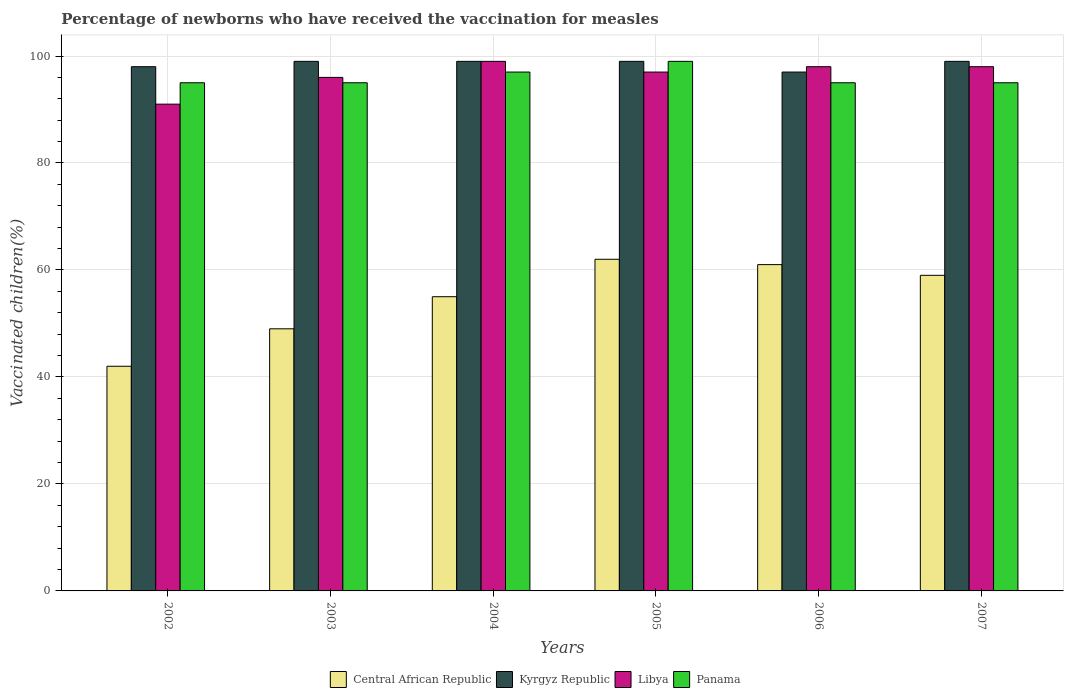How many different coloured bars are there?
Your response must be concise. 4. How many bars are there on the 6th tick from the left?
Your answer should be very brief. 4. How many bars are there on the 2nd tick from the right?
Keep it short and to the point. 4. In how many cases, is the number of bars for a given year not equal to the number of legend labels?
Offer a terse response. 0. What is the percentage of vaccinated children in Kyrgyz Republic in 2006?
Your answer should be very brief. 97. Across all years, what is the maximum percentage of vaccinated children in Kyrgyz Republic?
Provide a succinct answer. 99. Across all years, what is the minimum percentage of vaccinated children in Libya?
Offer a very short reply. 91. In which year was the percentage of vaccinated children in Panama maximum?
Give a very brief answer. 2005. What is the total percentage of vaccinated children in Kyrgyz Republic in the graph?
Your response must be concise. 591. What is the difference between the percentage of vaccinated children in Panama in 2003 and that in 2007?
Offer a terse response. 0. What is the difference between the percentage of vaccinated children in Central African Republic in 2007 and the percentage of vaccinated children in Libya in 2002?
Your answer should be compact. -32. What is the average percentage of vaccinated children in Libya per year?
Provide a short and direct response. 96.5. In the year 2004, what is the difference between the percentage of vaccinated children in Panama and percentage of vaccinated children in Kyrgyz Republic?
Keep it short and to the point. -2. In how many years, is the percentage of vaccinated children in Panama greater than 44 %?
Your answer should be very brief. 6. What is the ratio of the percentage of vaccinated children in Panama in 2004 to that in 2005?
Your response must be concise. 0.98. Is the difference between the percentage of vaccinated children in Panama in 2002 and 2004 greater than the difference between the percentage of vaccinated children in Kyrgyz Republic in 2002 and 2004?
Offer a terse response. No. What is the difference between the highest and the second highest percentage of vaccinated children in Libya?
Make the answer very short. 1. In how many years, is the percentage of vaccinated children in Central African Republic greater than the average percentage of vaccinated children in Central African Republic taken over all years?
Offer a very short reply. 4. What does the 2nd bar from the left in 2002 represents?
Make the answer very short. Kyrgyz Republic. What does the 1st bar from the right in 2002 represents?
Provide a succinct answer. Panama. Is it the case that in every year, the sum of the percentage of vaccinated children in Kyrgyz Republic and percentage of vaccinated children in Panama is greater than the percentage of vaccinated children in Libya?
Offer a very short reply. Yes. How many years are there in the graph?
Your answer should be compact. 6. Does the graph contain any zero values?
Your answer should be very brief. No. Does the graph contain grids?
Your answer should be very brief. Yes. Where does the legend appear in the graph?
Give a very brief answer. Bottom center. How are the legend labels stacked?
Provide a succinct answer. Horizontal. What is the title of the graph?
Give a very brief answer. Percentage of newborns who have received the vaccination for measles. Does "Yemen, Rep." appear as one of the legend labels in the graph?
Your response must be concise. No. What is the label or title of the Y-axis?
Offer a terse response. Vaccinated children(%). What is the Vaccinated children(%) in Libya in 2002?
Provide a short and direct response. 91. What is the Vaccinated children(%) in Panama in 2002?
Offer a very short reply. 95. What is the Vaccinated children(%) in Central African Republic in 2003?
Provide a succinct answer. 49. What is the Vaccinated children(%) of Libya in 2003?
Your response must be concise. 96. What is the Vaccinated children(%) of Panama in 2003?
Offer a terse response. 95. What is the Vaccinated children(%) of Central African Republic in 2004?
Provide a short and direct response. 55. What is the Vaccinated children(%) in Panama in 2004?
Give a very brief answer. 97. What is the Vaccinated children(%) of Central African Republic in 2005?
Your response must be concise. 62. What is the Vaccinated children(%) of Kyrgyz Republic in 2005?
Offer a terse response. 99. What is the Vaccinated children(%) of Libya in 2005?
Make the answer very short. 97. What is the Vaccinated children(%) in Panama in 2005?
Your response must be concise. 99. What is the Vaccinated children(%) in Kyrgyz Republic in 2006?
Provide a succinct answer. 97. What is the Vaccinated children(%) in Libya in 2006?
Keep it short and to the point. 98. What is the Vaccinated children(%) of Panama in 2006?
Offer a very short reply. 95. What is the Vaccinated children(%) of Kyrgyz Republic in 2007?
Keep it short and to the point. 99. What is the Vaccinated children(%) of Libya in 2007?
Your answer should be compact. 98. Across all years, what is the maximum Vaccinated children(%) of Central African Republic?
Make the answer very short. 62. Across all years, what is the maximum Vaccinated children(%) of Kyrgyz Republic?
Give a very brief answer. 99. Across all years, what is the maximum Vaccinated children(%) in Libya?
Provide a succinct answer. 99. Across all years, what is the minimum Vaccinated children(%) in Central African Republic?
Ensure brevity in your answer.  42. Across all years, what is the minimum Vaccinated children(%) in Kyrgyz Republic?
Make the answer very short. 97. Across all years, what is the minimum Vaccinated children(%) of Libya?
Offer a very short reply. 91. Across all years, what is the minimum Vaccinated children(%) of Panama?
Your answer should be compact. 95. What is the total Vaccinated children(%) in Central African Republic in the graph?
Provide a succinct answer. 328. What is the total Vaccinated children(%) in Kyrgyz Republic in the graph?
Offer a very short reply. 591. What is the total Vaccinated children(%) in Libya in the graph?
Your response must be concise. 579. What is the total Vaccinated children(%) in Panama in the graph?
Offer a terse response. 576. What is the difference between the Vaccinated children(%) in Central African Republic in 2002 and that in 2003?
Provide a succinct answer. -7. What is the difference between the Vaccinated children(%) of Panama in 2002 and that in 2004?
Give a very brief answer. -2. What is the difference between the Vaccinated children(%) of Panama in 2002 and that in 2005?
Provide a short and direct response. -4. What is the difference between the Vaccinated children(%) in Kyrgyz Republic in 2002 and that in 2006?
Your answer should be very brief. 1. What is the difference between the Vaccinated children(%) of Panama in 2002 and that in 2006?
Your response must be concise. 0. What is the difference between the Vaccinated children(%) in Kyrgyz Republic in 2002 and that in 2007?
Offer a very short reply. -1. What is the difference between the Vaccinated children(%) in Libya in 2002 and that in 2007?
Your answer should be very brief. -7. What is the difference between the Vaccinated children(%) in Kyrgyz Republic in 2003 and that in 2004?
Give a very brief answer. 0. What is the difference between the Vaccinated children(%) of Central African Republic in 2003 and that in 2005?
Keep it short and to the point. -13. What is the difference between the Vaccinated children(%) in Libya in 2003 and that in 2005?
Provide a succinct answer. -1. What is the difference between the Vaccinated children(%) in Panama in 2003 and that in 2005?
Keep it short and to the point. -4. What is the difference between the Vaccinated children(%) in Panama in 2003 and that in 2006?
Your answer should be very brief. 0. What is the difference between the Vaccinated children(%) in Central African Republic in 2003 and that in 2007?
Offer a very short reply. -10. What is the difference between the Vaccinated children(%) in Kyrgyz Republic in 2004 and that in 2005?
Keep it short and to the point. 0. What is the difference between the Vaccinated children(%) in Libya in 2004 and that in 2005?
Offer a terse response. 2. What is the difference between the Vaccinated children(%) of Panama in 2004 and that in 2005?
Offer a very short reply. -2. What is the difference between the Vaccinated children(%) in Kyrgyz Republic in 2004 and that in 2006?
Keep it short and to the point. 2. What is the difference between the Vaccinated children(%) in Libya in 2004 and that in 2006?
Your answer should be compact. 1. What is the difference between the Vaccinated children(%) in Panama in 2004 and that in 2007?
Provide a succinct answer. 2. What is the difference between the Vaccinated children(%) in Panama in 2005 and that in 2006?
Keep it short and to the point. 4. What is the difference between the Vaccinated children(%) of Central African Republic in 2005 and that in 2007?
Offer a very short reply. 3. What is the difference between the Vaccinated children(%) of Panama in 2005 and that in 2007?
Ensure brevity in your answer.  4. What is the difference between the Vaccinated children(%) of Central African Republic in 2006 and that in 2007?
Your answer should be compact. 2. What is the difference between the Vaccinated children(%) of Kyrgyz Republic in 2006 and that in 2007?
Your response must be concise. -2. What is the difference between the Vaccinated children(%) in Panama in 2006 and that in 2007?
Offer a terse response. 0. What is the difference between the Vaccinated children(%) in Central African Republic in 2002 and the Vaccinated children(%) in Kyrgyz Republic in 2003?
Your answer should be compact. -57. What is the difference between the Vaccinated children(%) of Central African Republic in 2002 and the Vaccinated children(%) of Libya in 2003?
Your answer should be very brief. -54. What is the difference between the Vaccinated children(%) of Central African Republic in 2002 and the Vaccinated children(%) of Panama in 2003?
Offer a terse response. -53. What is the difference between the Vaccinated children(%) in Kyrgyz Republic in 2002 and the Vaccinated children(%) in Libya in 2003?
Your response must be concise. 2. What is the difference between the Vaccinated children(%) in Libya in 2002 and the Vaccinated children(%) in Panama in 2003?
Provide a succinct answer. -4. What is the difference between the Vaccinated children(%) of Central African Republic in 2002 and the Vaccinated children(%) of Kyrgyz Republic in 2004?
Your answer should be very brief. -57. What is the difference between the Vaccinated children(%) in Central African Republic in 2002 and the Vaccinated children(%) in Libya in 2004?
Keep it short and to the point. -57. What is the difference between the Vaccinated children(%) in Central African Republic in 2002 and the Vaccinated children(%) in Panama in 2004?
Offer a very short reply. -55. What is the difference between the Vaccinated children(%) in Kyrgyz Republic in 2002 and the Vaccinated children(%) in Libya in 2004?
Give a very brief answer. -1. What is the difference between the Vaccinated children(%) of Central African Republic in 2002 and the Vaccinated children(%) of Kyrgyz Republic in 2005?
Your answer should be compact. -57. What is the difference between the Vaccinated children(%) of Central African Republic in 2002 and the Vaccinated children(%) of Libya in 2005?
Your answer should be very brief. -55. What is the difference between the Vaccinated children(%) of Central African Republic in 2002 and the Vaccinated children(%) of Panama in 2005?
Give a very brief answer. -57. What is the difference between the Vaccinated children(%) of Kyrgyz Republic in 2002 and the Vaccinated children(%) of Libya in 2005?
Provide a succinct answer. 1. What is the difference between the Vaccinated children(%) of Kyrgyz Republic in 2002 and the Vaccinated children(%) of Panama in 2005?
Your answer should be compact. -1. What is the difference between the Vaccinated children(%) in Libya in 2002 and the Vaccinated children(%) in Panama in 2005?
Make the answer very short. -8. What is the difference between the Vaccinated children(%) in Central African Republic in 2002 and the Vaccinated children(%) in Kyrgyz Republic in 2006?
Ensure brevity in your answer.  -55. What is the difference between the Vaccinated children(%) of Central African Republic in 2002 and the Vaccinated children(%) of Libya in 2006?
Make the answer very short. -56. What is the difference between the Vaccinated children(%) in Central African Republic in 2002 and the Vaccinated children(%) in Panama in 2006?
Provide a short and direct response. -53. What is the difference between the Vaccinated children(%) in Libya in 2002 and the Vaccinated children(%) in Panama in 2006?
Give a very brief answer. -4. What is the difference between the Vaccinated children(%) of Central African Republic in 2002 and the Vaccinated children(%) of Kyrgyz Republic in 2007?
Ensure brevity in your answer.  -57. What is the difference between the Vaccinated children(%) in Central African Republic in 2002 and the Vaccinated children(%) in Libya in 2007?
Your answer should be compact. -56. What is the difference between the Vaccinated children(%) in Central African Republic in 2002 and the Vaccinated children(%) in Panama in 2007?
Ensure brevity in your answer.  -53. What is the difference between the Vaccinated children(%) in Kyrgyz Republic in 2002 and the Vaccinated children(%) in Libya in 2007?
Provide a succinct answer. 0. What is the difference between the Vaccinated children(%) in Kyrgyz Republic in 2002 and the Vaccinated children(%) in Panama in 2007?
Your answer should be compact. 3. What is the difference between the Vaccinated children(%) in Libya in 2002 and the Vaccinated children(%) in Panama in 2007?
Your answer should be compact. -4. What is the difference between the Vaccinated children(%) of Central African Republic in 2003 and the Vaccinated children(%) of Kyrgyz Republic in 2004?
Offer a terse response. -50. What is the difference between the Vaccinated children(%) in Central African Republic in 2003 and the Vaccinated children(%) in Libya in 2004?
Offer a terse response. -50. What is the difference between the Vaccinated children(%) of Central African Republic in 2003 and the Vaccinated children(%) of Panama in 2004?
Your answer should be compact. -48. What is the difference between the Vaccinated children(%) in Kyrgyz Republic in 2003 and the Vaccinated children(%) in Panama in 2004?
Ensure brevity in your answer.  2. What is the difference between the Vaccinated children(%) in Central African Republic in 2003 and the Vaccinated children(%) in Kyrgyz Republic in 2005?
Offer a terse response. -50. What is the difference between the Vaccinated children(%) in Central African Republic in 2003 and the Vaccinated children(%) in Libya in 2005?
Offer a terse response. -48. What is the difference between the Vaccinated children(%) in Libya in 2003 and the Vaccinated children(%) in Panama in 2005?
Offer a terse response. -3. What is the difference between the Vaccinated children(%) in Central African Republic in 2003 and the Vaccinated children(%) in Kyrgyz Republic in 2006?
Provide a succinct answer. -48. What is the difference between the Vaccinated children(%) in Central African Republic in 2003 and the Vaccinated children(%) in Libya in 2006?
Give a very brief answer. -49. What is the difference between the Vaccinated children(%) of Central African Republic in 2003 and the Vaccinated children(%) of Panama in 2006?
Offer a terse response. -46. What is the difference between the Vaccinated children(%) of Kyrgyz Republic in 2003 and the Vaccinated children(%) of Panama in 2006?
Offer a very short reply. 4. What is the difference between the Vaccinated children(%) in Central African Republic in 2003 and the Vaccinated children(%) in Kyrgyz Republic in 2007?
Your answer should be compact. -50. What is the difference between the Vaccinated children(%) of Central African Republic in 2003 and the Vaccinated children(%) of Libya in 2007?
Offer a terse response. -49. What is the difference between the Vaccinated children(%) of Central African Republic in 2003 and the Vaccinated children(%) of Panama in 2007?
Provide a succinct answer. -46. What is the difference between the Vaccinated children(%) of Kyrgyz Republic in 2003 and the Vaccinated children(%) of Libya in 2007?
Offer a terse response. 1. What is the difference between the Vaccinated children(%) of Kyrgyz Republic in 2003 and the Vaccinated children(%) of Panama in 2007?
Offer a very short reply. 4. What is the difference between the Vaccinated children(%) in Central African Republic in 2004 and the Vaccinated children(%) in Kyrgyz Republic in 2005?
Give a very brief answer. -44. What is the difference between the Vaccinated children(%) in Central African Republic in 2004 and the Vaccinated children(%) in Libya in 2005?
Offer a very short reply. -42. What is the difference between the Vaccinated children(%) in Central African Republic in 2004 and the Vaccinated children(%) in Panama in 2005?
Provide a short and direct response. -44. What is the difference between the Vaccinated children(%) of Central African Republic in 2004 and the Vaccinated children(%) of Kyrgyz Republic in 2006?
Make the answer very short. -42. What is the difference between the Vaccinated children(%) of Central African Republic in 2004 and the Vaccinated children(%) of Libya in 2006?
Give a very brief answer. -43. What is the difference between the Vaccinated children(%) in Kyrgyz Republic in 2004 and the Vaccinated children(%) in Libya in 2006?
Offer a terse response. 1. What is the difference between the Vaccinated children(%) of Kyrgyz Republic in 2004 and the Vaccinated children(%) of Panama in 2006?
Offer a terse response. 4. What is the difference between the Vaccinated children(%) in Central African Republic in 2004 and the Vaccinated children(%) in Kyrgyz Republic in 2007?
Give a very brief answer. -44. What is the difference between the Vaccinated children(%) of Central African Republic in 2004 and the Vaccinated children(%) of Libya in 2007?
Your response must be concise. -43. What is the difference between the Vaccinated children(%) in Kyrgyz Republic in 2004 and the Vaccinated children(%) in Libya in 2007?
Give a very brief answer. 1. What is the difference between the Vaccinated children(%) of Libya in 2004 and the Vaccinated children(%) of Panama in 2007?
Your response must be concise. 4. What is the difference between the Vaccinated children(%) in Central African Republic in 2005 and the Vaccinated children(%) in Kyrgyz Republic in 2006?
Make the answer very short. -35. What is the difference between the Vaccinated children(%) of Central African Republic in 2005 and the Vaccinated children(%) of Libya in 2006?
Make the answer very short. -36. What is the difference between the Vaccinated children(%) in Central African Republic in 2005 and the Vaccinated children(%) in Panama in 2006?
Your answer should be compact. -33. What is the difference between the Vaccinated children(%) in Kyrgyz Republic in 2005 and the Vaccinated children(%) in Libya in 2006?
Keep it short and to the point. 1. What is the difference between the Vaccinated children(%) of Libya in 2005 and the Vaccinated children(%) of Panama in 2006?
Provide a short and direct response. 2. What is the difference between the Vaccinated children(%) in Central African Republic in 2005 and the Vaccinated children(%) in Kyrgyz Republic in 2007?
Your response must be concise. -37. What is the difference between the Vaccinated children(%) of Central African Republic in 2005 and the Vaccinated children(%) of Libya in 2007?
Ensure brevity in your answer.  -36. What is the difference between the Vaccinated children(%) of Central African Republic in 2005 and the Vaccinated children(%) of Panama in 2007?
Ensure brevity in your answer.  -33. What is the difference between the Vaccinated children(%) of Kyrgyz Republic in 2005 and the Vaccinated children(%) of Libya in 2007?
Your response must be concise. 1. What is the difference between the Vaccinated children(%) in Central African Republic in 2006 and the Vaccinated children(%) in Kyrgyz Republic in 2007?
Keep it short and to the point. -38. What is the difference between the Vaccinated children(%) in Central African Republic in 2006 and the Vaccinated children(%) in Libya in 2007?
Give a very brief answer. -37. What is the difference between the Vaccinated children(%) in Central African Republic in 2006 and the Vaccinated children(%) in Panama in 2007?
Provide a short and direct response. -34. What is the difference between the Vaccinated children(%) in Kyrgyz Republic in 2006 and the Vaccinated children(%) in Libya in 2007?
Keep it short and to the point. -1. What is the difference between the Vaccinated children(%) in Libya in 2006 and the Vaccinated children(%) in Panama in 2007?
Your answer should be compact. 3. What is the average Vaccinated children(%) of Central African Republic per year?
Make the answer very short. 54.67. What is the average Vaccinated children(%) in Kyrgyz Republic per year?
Give a very brief answer. 98.5. What is the average Vaccinated children(%) of Libya per year?
Ensure brevity in your answer.  96.5. What is the average Vaccinated children(%) in Panama per year?
Provide a short and direct response. 96. In the year 2002, what is the difference between the Vaccinated children(%) of Central African Republic and Vaccinated children(%) of Kyrgyz Republic?
Ensure brevity in your answer.  -56. In the year 2002, what is the difference between the Vaccinated children(%) of Central African Republic and Vaccinated children(%) of Libya?
Offer a terse response. -49. In the year 2002, what is the difference between the Vaccinated children(%) in Central African Republic and Vaccinated children(%) in Panama?
Provide a short and direct response. -53. In the year 2002, what is the difference between the Vaccinated children(%) of Kyrgyz Republic and Vaccinated children(%) of Libya?
Your response must be concise. 7. In the year 2002, what is the difference between the Vaccinated children(%) in Kyrgyz Republic and Vaccinated children(%) in Panama?
Make the answer very short. 3. In the year 2003, what is the difference between the Vaccinated children(%) of Central African Republic and Vaccinated children(%) of Kyrgyz Republic?
Your response must be concise. -50. In the year 2003, what is the difference between the Vaccinated children(%) in Central African Republic and Vaccinated children(%) in Libya?
Provide a succinct answer. -47. In the year 2003, what is the difference between the Vaccinated children(%) in Central African Republic and Vaccinated children(%) in Panama?
Your answer should be very brief. -46. In the year 2003, what is the difference between the Vaccinated children(%) of Kyrgyz Republic and Vaccinated children(%) of Libya?
Ensure brevity in your answer.  3. In the year 2003, what is the difference between the Vaccinated children(%) in Kyrgyz Republic and Vaccinated children(%) in Panama?
Your answer should be compact. 4. In the year 2003, what is the difference between the Vaccinated children(%) in Libya and Vaccinated children(%) in Panama?
Make the answer very short. 1. In the year 2004, what is the difference between the Vaccinated children(%) in Central African Republic and Vaccinated children(%) in Kyrgyz Republic?
Provide a succinct answer. -44. In the year 2004, what is the difference between the Vaccinated children(%) of Central African Republic and Vaccinated children(%) of Libya?
Your response must be concise. -44. In the year 2004, what is the difference between the Vaccinated children(%) in Central African Republic and Vaccinated children(%) in Panama?
Your answer should be compact. -42. In the year 2004, what is the difference between the Vaccinated children(%) of Kyrgyz Republic and Vaccinated children(%) of Panama?
Your answer should be very brief. 2. In the year 2004, what is the difference between the Vaccinated children(%) of Libya and Vaccinated children(%) of Panama?
Your answer should be very brief. 2. In the year 2005, what is the difference between the Vaccinated children(%) of Central African Republic and Vaccinated children(%) of Kyrgyz Republic?
Give a very brief answer. -37. In the year 2005, what is the difference between the Vaccinated children(%) in Central African Republic and Vaccinated children(%) in Libya?
Your answer should be very brief. -35. In the year 2005, what is the difference between the Vaccinated children(%) of Central African Republic and Vaccinated children(%) of Panama?
Ensure brevity in your answer.  -37. In the year 2005, what is the difference between the Vaccinated children(%) in Kyrgyz Republic and Vaccinated children(%) in Panama?
Provide a succinct answer. 0. In the year 2006, what is the difference between the Vaccinated children(%) of Central African Republic and Vaccinated children(%) of Kyrgyz Republic?
Provide a succinct answer. -36. In the year 2006, what is the difference between the Vaccinated children(%) of Central African Republic and Vaccinated children(%) of Libya?
Ensure brevity in your answer.  -37. In the year 2006, what is the difference between the Vaccinated children(%) of Central African Republic and Vaccinated children(%) of Panama?
Your answer should be very brief. -34. In the year 2007, what is the difference between the Vaccinated children(%) of Central African Republic and Vaccinated children(%) of Libya?
Ensure brevity in your answer.  -39. In the year 2007, what is the difference between the Vaccinated children(%) of Central African Republic and Vaccinated children(%) of Panama?
Your answer should be compact. -36. In the year 2007, what is the difference between the Vaccinated children(%) of Kyrgyz Republic and Vaccinated children(%) of Libya?
Ensure brevity in your answer.  1. In the year 2007, what is the difference between the Vaccinated children(%) in Kyrgyz Republic and Vaccinated children(%) in Panama?
Offer a very short reply. 4. In the year 2007, what is the difference between the Vaccinated children(%) in Libya and Vaccinated children(%) in Panama?
Ensure brevity in your answer.  3. What is the ratio of the Vaccinated children(%) in Kyrgyz Republic in 2002 to that in 2003?
Keep it short and to the point. 0.99. What is the ratio of the Vaccinated children(%) in Libya in 2002 to that in 2003?
Make the answer very short. 0.95. What is the ratio of the Vaccinated children(%) of Panama in 2002 to that in 2003?
Provide a short and direct response. 1. What is the ratio of the Vaccinated children(%) in Central African Republic in 2002 to that in 2004?
Offer a very short reply. 0.76. What is the ratio of the Vaccinated children(%) in Kyrgyz Republic in 2002 to that in 2004?
Give a very brief answer. 0.99. What is the ratio of the Vaccinated children(%) of Libya in 2002 to that in 2004?
Your answer should be very brief. 0.92. What is the ratio of the Vaccinated children(%) of Panama in 2002 to that in 2004?
Your response must be concise. 0.98. What is the ratio of the Vaccinated children(%) of Central African Republic in 2002 to that in 2005?
Give a very brief answer. 0.68. What is the ratio of the Vaccinated children(%) of Libya in 2002 to that in 2005?
Ensure brevity in your answer.  0.94. What is the ratio of the Vaccinated children(%) in Panama in 2002 to that in 2005?
Provide a succinct answer. 0.96. What is the ratio of the Vaccinated children(%) in Central African Republic in 2002 to that in 2006?
Make the answer very short. 0.69. What is the ratio of the Vaccinated children(%) of Kyrgyz Republic in 2002 to that in 2006?
Give a very brief answer. 1.01. What is the ratio of the Vaccinated children(%) in Central African Republic in 2002 to that in 2007?
Provide a short and direct response. 0.71. What is the ratio of the Vaccinated children(%) in Kyrgyz Republic in 2002 to that in 2007?
Your response must be concise. 0.99. What is the ratio of the Vaccinated children(%) in Central African Republic in 2003 to that in 2004?
Your response must be concise. 0.89. What is the ratio of the Vaccinated children(%) of Kyrgyz Republic in 2003 to that in 2004?
Offer a terse response. 1. What is the ratio of the Vaccinated children(%) of Libya in 2003 to that in 2004?
Provide a short and direct response. 0.97. What is the ratio of the Vaccinated children(%) in Panama in 2003 to that in 2004?
Offer a terse response. 0.98. What is the ratio of the Vaccinated children(%) in Central African Republic in 2003 to that in 2005?
Provide a short and direct response. 0.79. What is the ratio of the Vaccinated children(%) of Kyrgyz Republic in 2003 to that in 2005?
Your answer should be compact. 1. What is the ratio of the Vaccinated children(%) of Libya in 2003 to that in 2005?
Offer a terse response. 0.99. What is the ratio of the Vaccinated children(%) of Panama in 2003 to that in 2005?
Your response must be concise. 0.96. What is the ratio of the Vaccinated children(%) in Central African Republic in 2003 to that in 2006?
Your answer should be very brief. 0.8. What is the ratio of the Vaccinated children(%) in Kyrgyz Republic in 2003 to that in 2006?
Offer a very short reply. 1.02. What is the ratio of the Vaccinated children(%) in Libya in 2003 to that in 2006?
Keep it short and to the point. 0.98. What is the ratio of the Vaccinated children(%) of Panama in 2003 to that in 2006?
Ensure brevity in your answer.  1. What is the ratio of the Vaccinated children(%) of Central African Republic in 2003 to that in 2007?
Provide a short and direct response. 0.83. What is the ratio of the Vaccinated children(%) of Libya in 2003 to that in 2007?
Give a very brief answer. 0.98. What is the ratio of the Vaccinated children(%) in Panama in 2003 to that in 2007?
Provide a succinct answer. 1. What is the ratio of the Vaccinated children(%) in Central African Republic in 2004 to that in 2005?
Keep it short and to the point. 0.89. What is the ratio of the Vaccinated children(%) of Kyrgyz Republic in 2004 to that in 2005?
Offer a very short reply. 1. What is the ratio of the Vaccinated children(%) in Libya in 2004 to that in 2005?
Ensure brevity in your answer.  1.02. What is the ratio of the Vaccinated children(%) in Panama in 2004 to that in 2005?
Keep it short and to the point. 0.98. What is the ratio of the Vaccinated children(%) in Central African Republic in 2004 to that in 2006?
Your answer should be compact. 0.9. What is the ratio of the Vaccinated children(%) of Kyrgyz Republic in 2004 to that in 2006?
Offer a very short reply. 1.02. What is the ratio of the Vaccinated children(%) in Libya in 2004 to that in 2006?
Ensure brevity in your answer.  1.01. What is the ratio of the Vaccinated children(%) in Panama in 2004 to that in 2006?
Provide a succinct answer. 1.02. What is the ratio of the Vaccinated children(%) in Central African Republic in 2004 to that in 2007?
Offer a terse response. 0.93. What is the ratio of the Vaccinated children(%) in Kyrgyz Republic in 2004 to that in 2007?
Provide a succinct answer. 1. What is the ratio of the Vaccinated children(%) of Libya in 2004 to that in 2007?
Make the answer very short. 1.01. What is the ratio of the Vaccinated children(%) in Panama in 2004 to that in 2007?
Keep it short and to the point. 1.02. What is the ratio of the Vaccinated children(%) in Central African Republic in 2005 to that in 2006?
Offer a terse response. 1.02. What is the ratio of the Vaccinated children(%) in Kyrgyz Republic in 2005 to that in 2006?
Ensure brevity in your answer.  1.02. What is the ratio of the Vaccinated children(%) in Panama in 2005 to that in 2006?
Provide a succinct answer. 1.04. What is the ratio of the Vaccinated children(%) in Central African Republic in 2005 to that in 2007?
Give a very brief answer. 1.05. What is the ratio of the Vaccinated children(%) of Kyrgyz Republic in 2005 to that in 2007?
Keep it short and to the point. 1. What is the ratio of the Vaccinated children(%) of Panama in 2005 to that in 2007?
Provide a short and direct response. 1.04. What is the ratio of the Vaccinated children(%) of Central African Republic in 2006 to that in 2007?
Provide a short and direct response. 1.03. What is the ratio of the Vaccinated children(%) of Kyrgyz Republic in 2006 to that in 2007?
Provide a succinct answer. 0.98. What is the ratio of the Vaccinated children(%) in Libya in 2006 to that in 2007?
Your answer should be very brief. 1. What is the difference between the highest and the second highest Vaccinated children(%) in Central African Republic?
Provide a succinct answer. 1. What is the difference between the highest and the second highest Vaccinated children(%) of Libya?
Give a very brief answer. 1. What is the difference between the highest and the second highest Vaccinated children(%) of Panama?
Offer a terse response. 2. What is the difference between the highest and the lowest Vaccinated children(%) of Kyrgyz Republic?
Your answer should be compact. 2. 